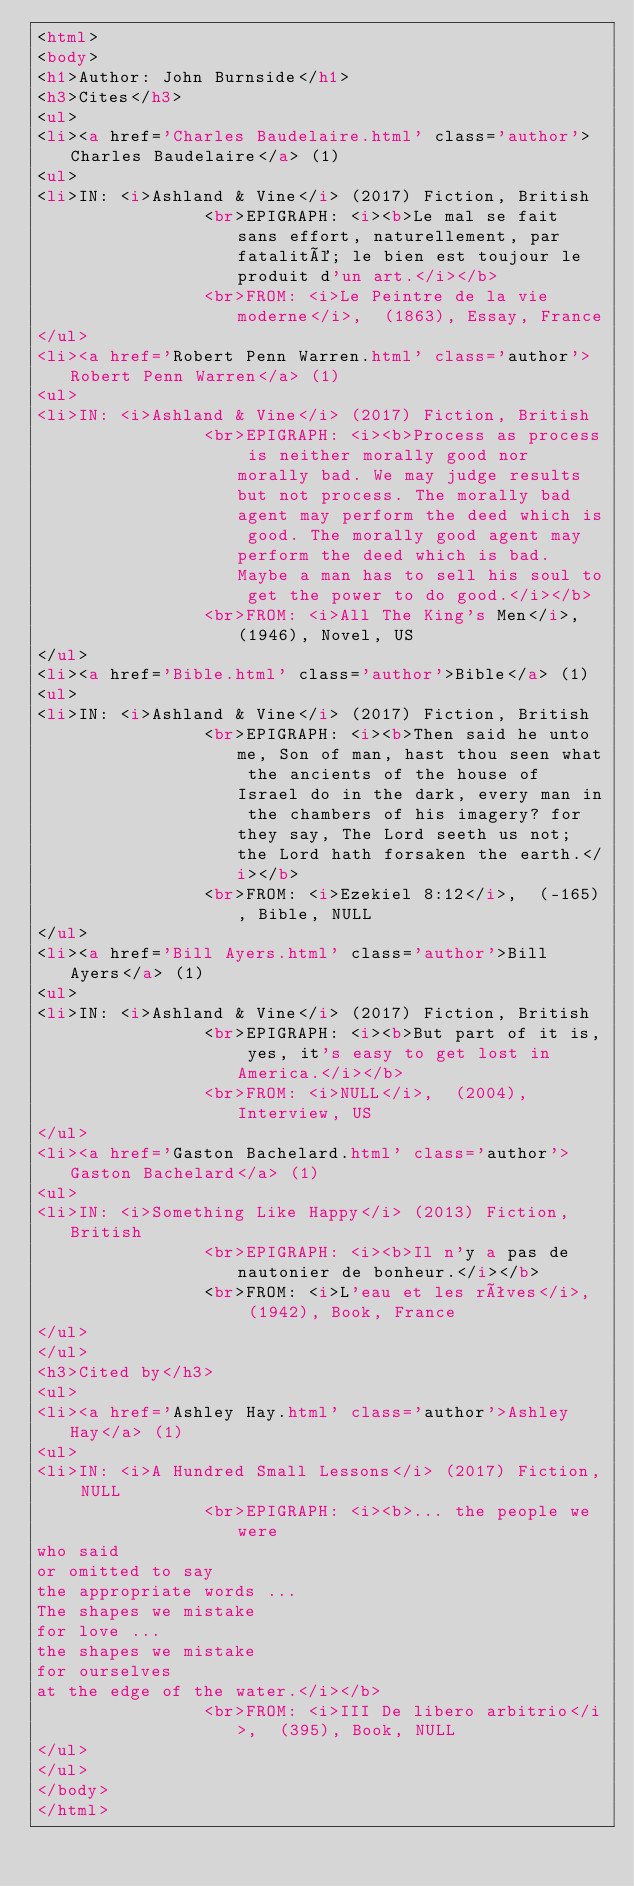<code> <loc_0><loc_0><loc_500><loc_500><_HTML_><html>
<body>
<h1>Author: John Burnside</h1>
<h3>Cites</h3>
<ul>
<li><a href='Charles Baudelaire.html' class='author'>Charles Baudelaire</a> (1)
<ul>
<li>IN: <i>Ashland & Vine</i> (2017) Fiction, British
                <br>EPIGRAPH: <i><b>Le mal se fait sans effort, naturellement, par fatalité; le bien est toujour le produit d'un art.</i></b>
                <br>FROM: <i>Le Peintre de la vie moderne</i>,  (1863), Essay, France
</ul>
<li><a href='Robert Penn Warren.html' class='author'>Robert Penn Warren</a> (1)
<ul>
<li>IN: <i>Ashland & Vine</i> (2017) Fiction, British
                <br>EPIGRAPH: <i><b>Process as process is neither morally good nor morally bad. We may judge results but not process. The morally bad agent may perform the deed which is good. The morally good agent may perform the deed which is bad. Maybe a man has to sell his soul to get the power to do good.</i></b>
                <br>FROM: <i>All The King's Men</i>,  (1946), Novel, US
</ul>
<li><a href='Bible.html' class='author'>Bible</a> (1)
<ul>
<li>IN: <i>Ashland & Vine</i> (2017) Fiction, British
                <br>EPIGRAPH: <i><b>Then said he unto me, Son of man, hast thou seen what the ancients of the house of Israel do in the dark, every man in the chambers of his imagery? for they say, The Lord seeth us not; the Lord hath forsaken the earth.</i></b>
                <br>FROM: <i>Ezekiel 8:12</i>,  (-165), Bible, NULL
</ul>
<li><a href='Bill Ayers.html' class='author'>Bill Ayers</a> (1)
<ul>
<li>IN: <i>Ashland & Vine</i> (2017) Fiction, British
                <br>EPIGRAPH: <i><b>But part of it is, yes, it's easy to get lost in America.</i></b>
                <br>FROM: <i>NULL</i>,  (2004), Interview, US
</ul>
<li><a href='Gaston Bachelard.html' class='author'>Gaston Bachelard</a> (1)
<ul>
<li>IN: <i>Something Like Happy</i> (2013) Fiction, British
                <br>EPIGRAPH: <i><b>Il n'y a pas de nautonier de bonheur.</i></b>
                <br>FROM: <i>L'eau et les rêves</i>,  (1942), Book, France
</ul>
</ul>
<h3>Cited by</h3>
<ul>
<li><a href='Ashley Hay.html' class='author'>Ashley Hay</a> (1)
<ul>
<li>IN: <i>A Hundred Small Lessons</i> (2017) Fiction, NULL
                <br>EPIGRAPH: <i><b>... the people we were
who said
or omitted to say
the appropriate words ... 
The shapes we mistake
for love ... 
the shapes we mistake
for ourselves
at the edge of the water.</i></b>
                <br>FROM: <i>III De libero arbitrio</i>,  (395), Book, NULL
</ul>
</ul>
</body>
</html>
</code> 